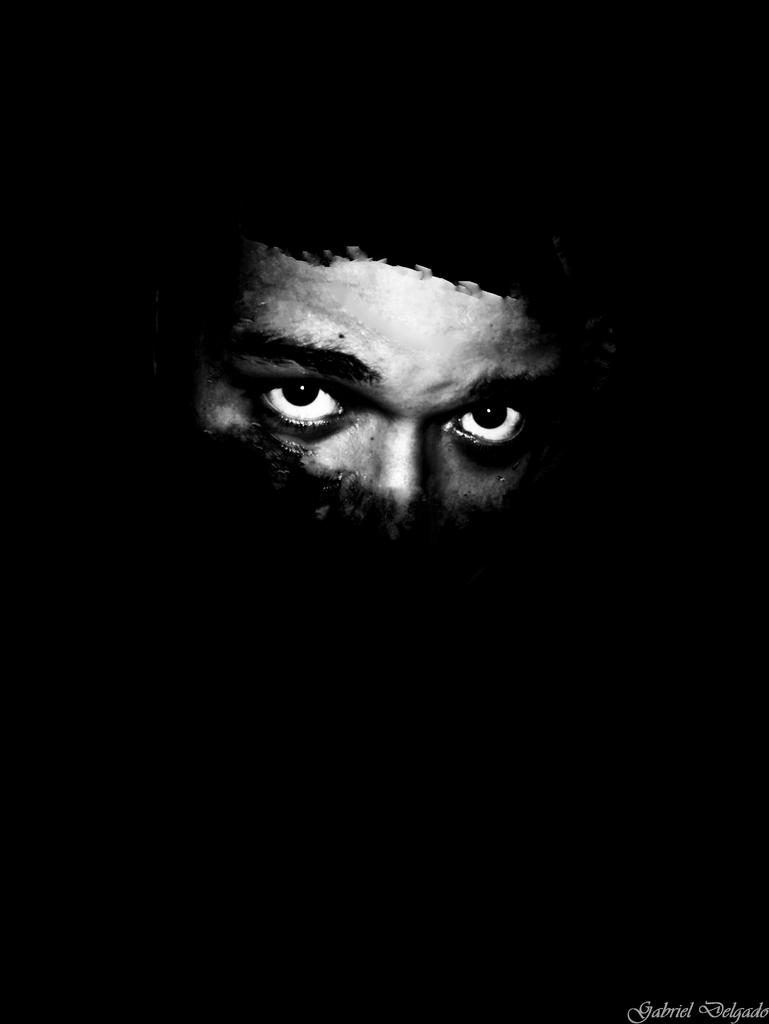What is the main subject of the image? There is a face of a person in the image. Where is the vase located in the image? There is no vase present in the image. What type of yard can be seen in the image? There is no yard present in the image; it only features the face of a person. 